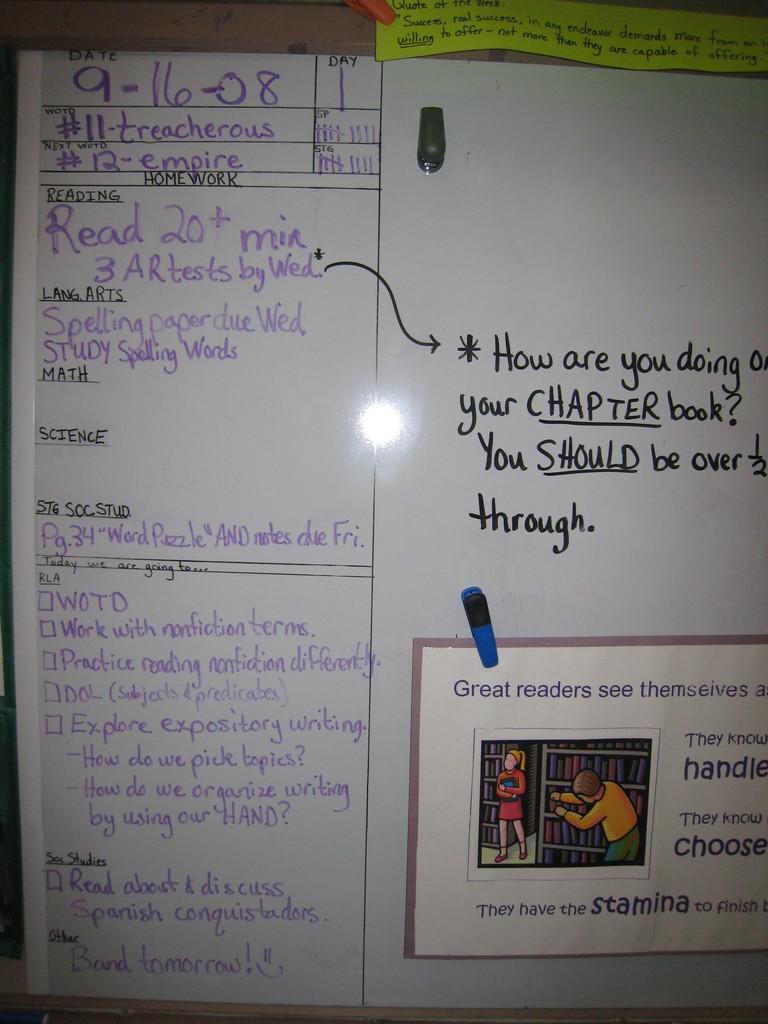When is the spelling paper due?
Your response must be concise. Wednesday. 